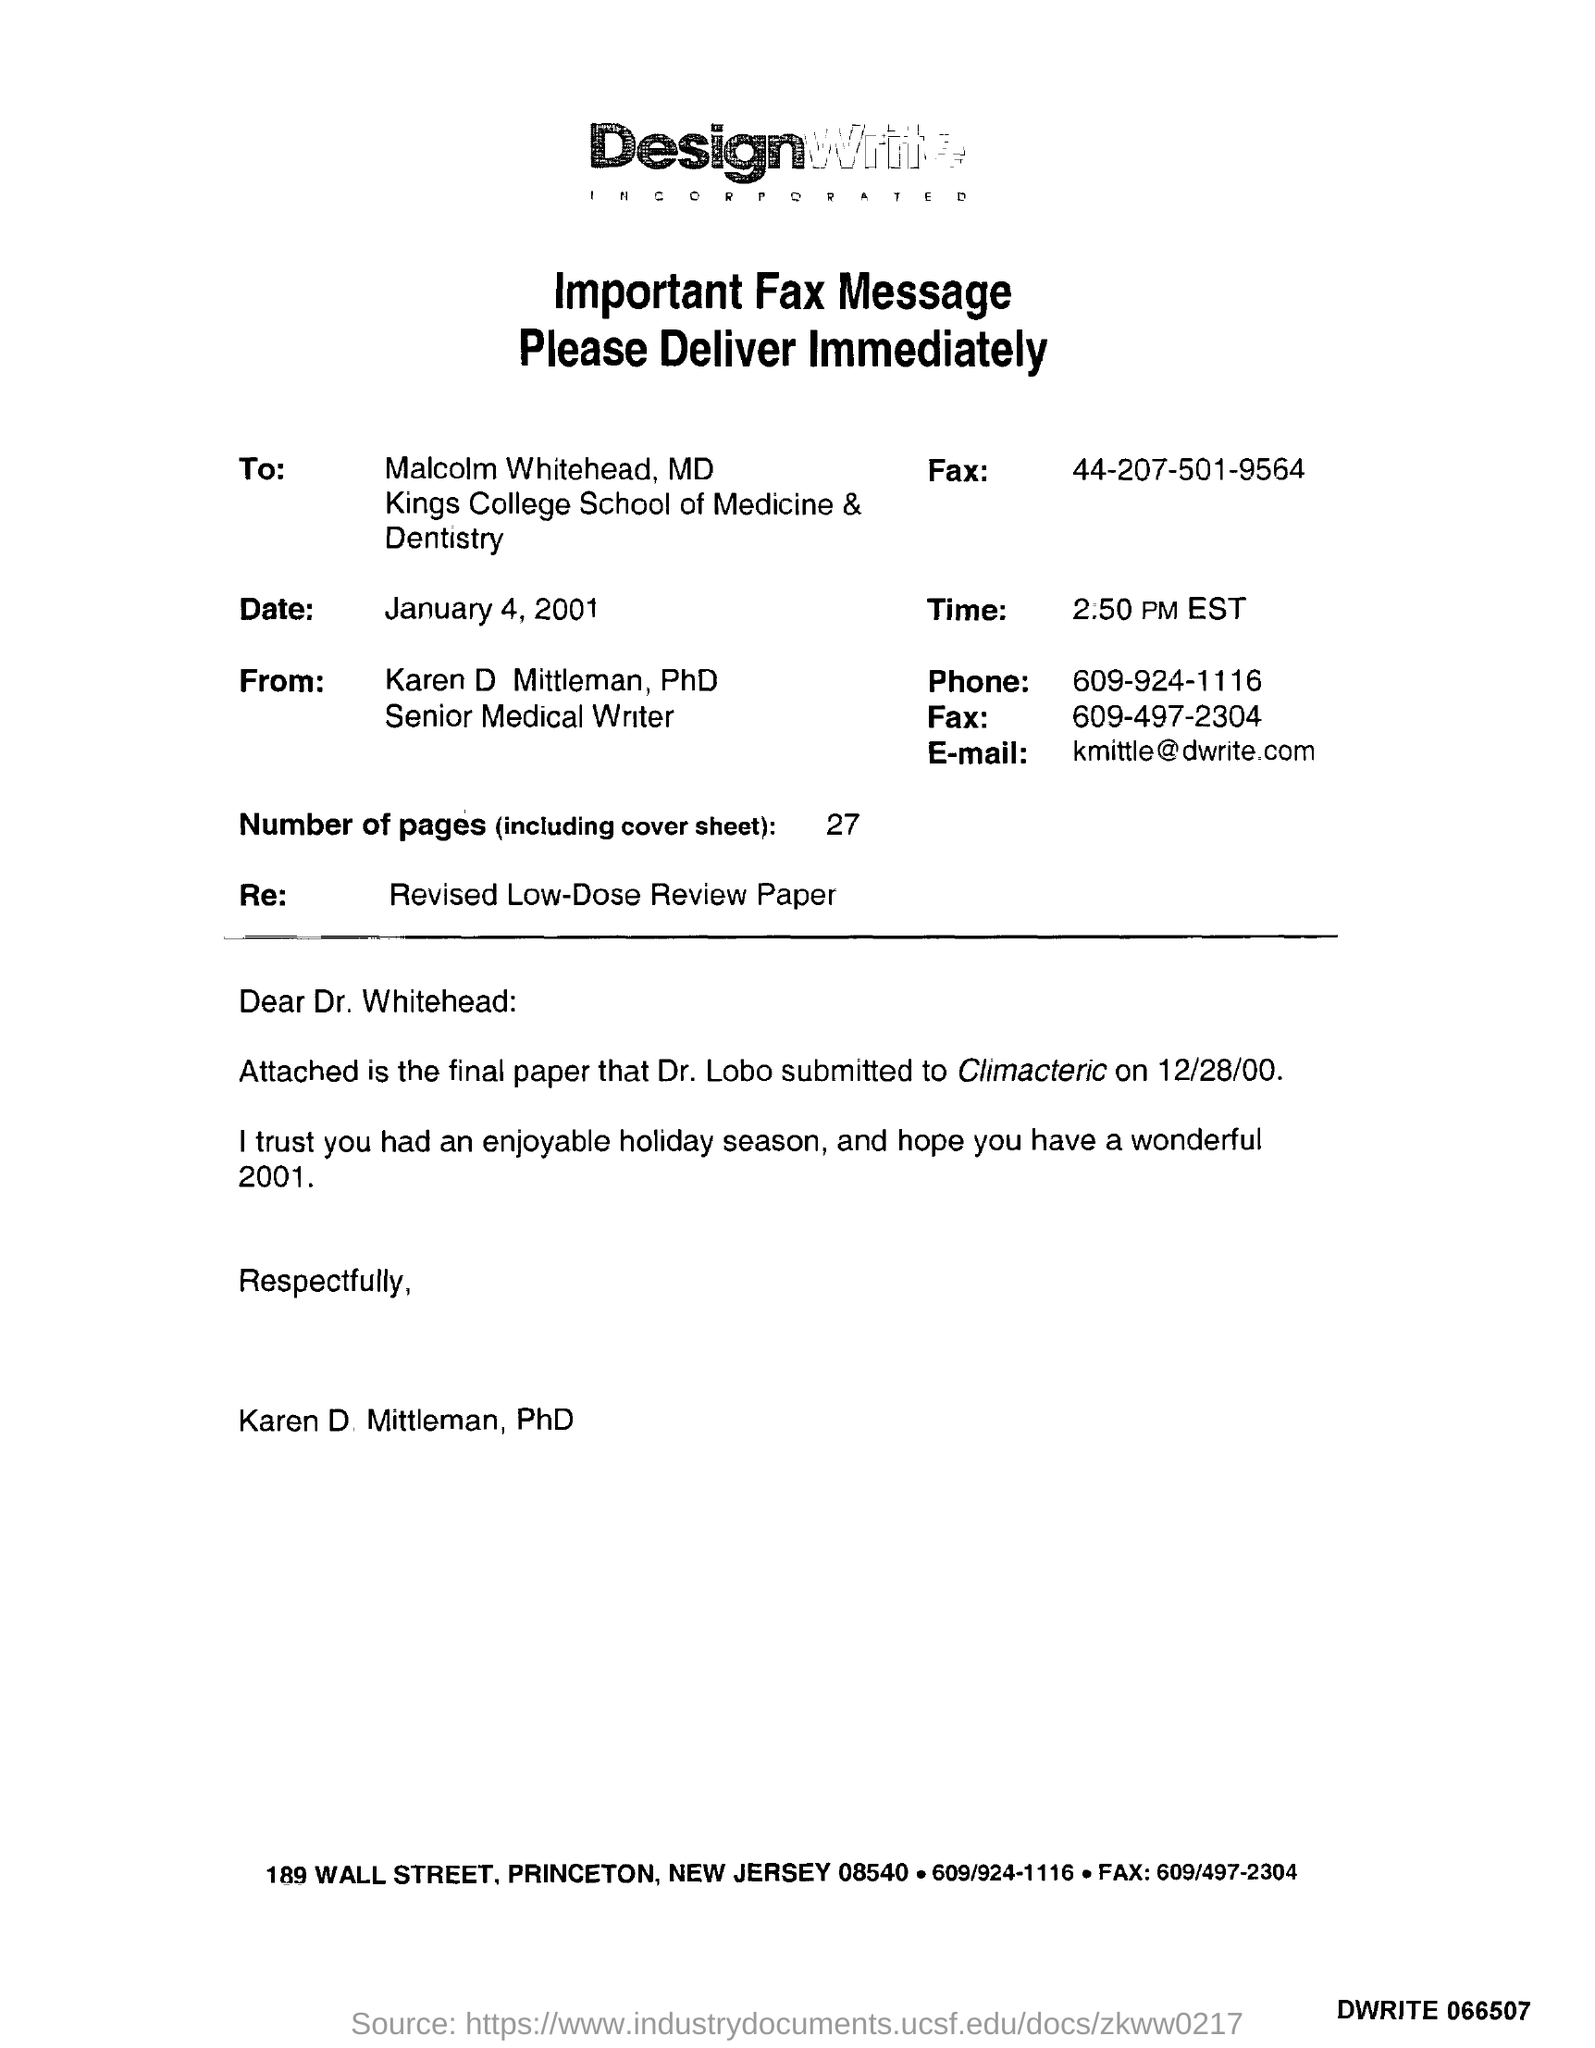What is the phone number of Senior medical writer?
Make the answer very short. 609-924-1116. When was the fax message sent?
Keep it short and to the point. January 4, 2001. 